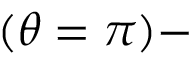Convert formula to latex. <formula><loc_0><loc_0><loc_500><loc_500>( \theta = \pi ) -</formula> 